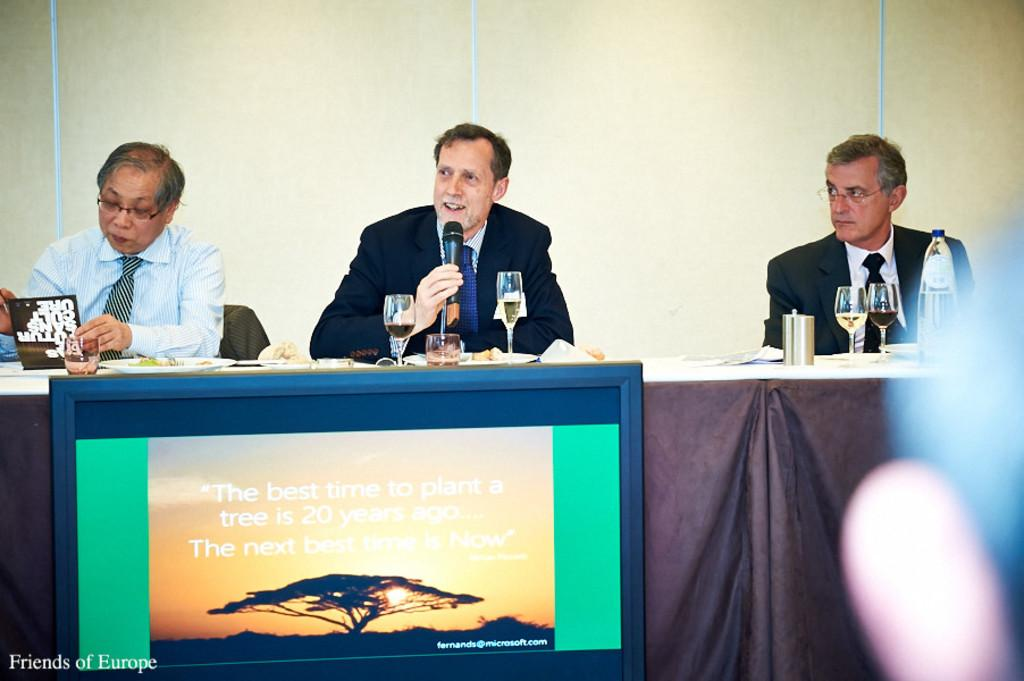<image>
Provide a brief description of the given image. Three men are sitting at table behind a screen that says "The next best time is Now". 